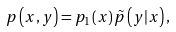Convert formula to latex. <formula><loc_0><loc_0><loc_500><loc_500>p \left ( x , y \right ) = p _ { 1 } \left ( x \right ) \tilde { p } \left ( y | x \right ) ,</formula> 